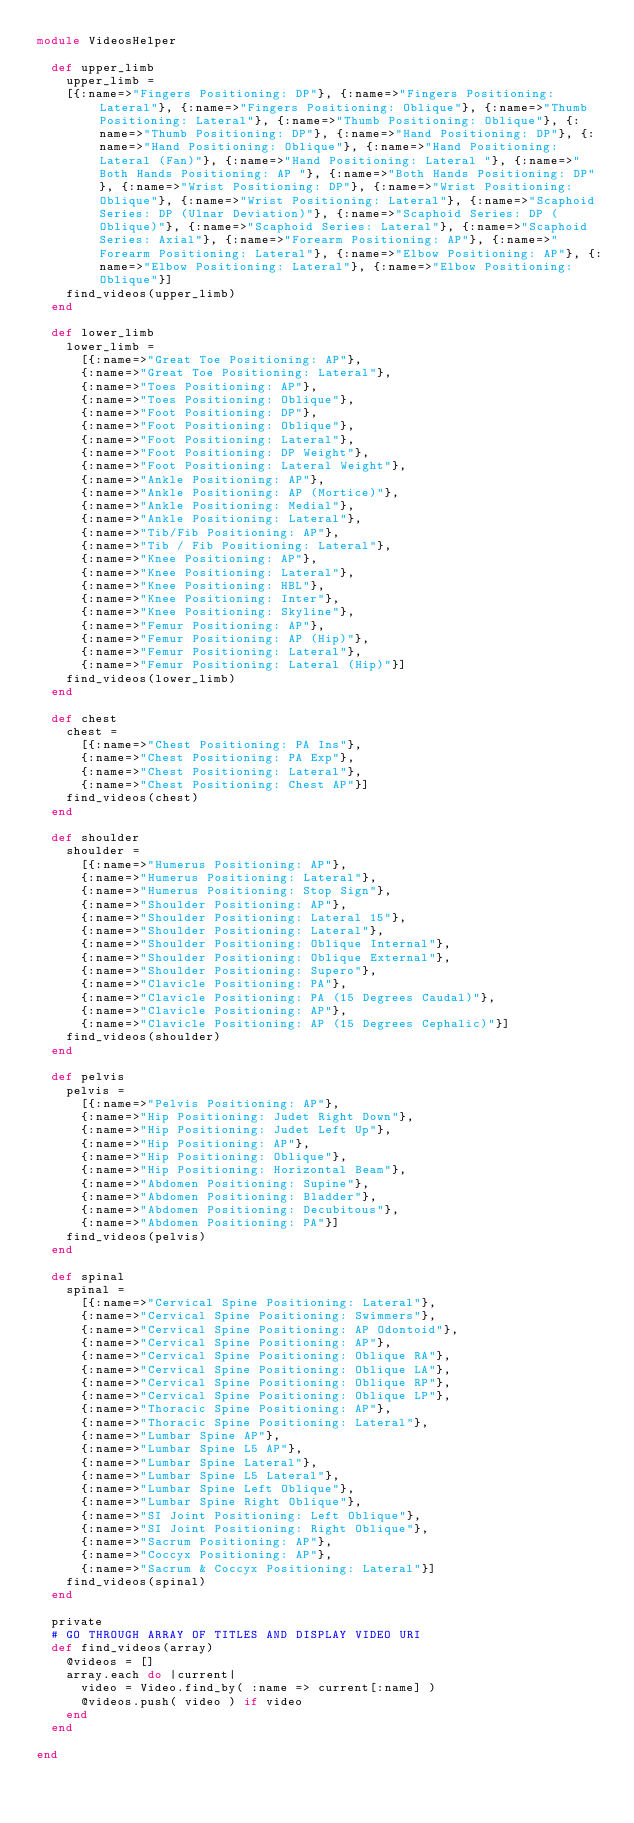<code> <loc_0><loc_0><loc_500><loc_500><_Ruby_>module VideosHelper

  def upper_limb
    upper_limb = 
    [{:name=>"Fingers Positioning: DP"}, {:name=>"Fingers Positioning: Lateral"}, {:name=>"Fingers Positioning: Oblique"}, {:name=>"Thumb Positioning: Lateral"}, {:name=>"Thumb Positioning: Oblique"}, {:name=>"Thumb Positioning: DP"}, {:name=>"Hand Positioning: DP"}, {:name=>"Hand Positioning: Oblique"}, {:name=>"Hand Positioning: Lateral (Fan)"}, {:name=>"Hand Positioning: Lateral "}, {:name=>"Both Hands Positioning: AP "}, {:name=>"Both Hands Positioning: DP"}, {:name=>"Wrist Positioning: DP"}, {:name=>"Wrist Positioning: Oblique"}, {:name=>"Wrist Positioning: Lateral"}, {:name=>"Scaphoid Series: DP (Ulnar Deviation)"}, {:name=>"Scaphoid Series: DP (Oblique)"}, {:name=>"Scaphoid Series: Lateral"}, {:name=>"Scaphoid Series: Axial"}, {:name=>"Forearm Positioning: AP"}, {:name=>"Forearm Positioning: Lateral"}, {:name=>"Elbow Positioning: AP"}, {:name=>"Elbow Positioning: Lateral"}, {:name=>"Elbow Positioning: Oblique"}]
    find_videos(upper_limb)
  end

  def lower_limb
    lower_limb = 
      [{:name=>"Great Toe Positioning: AP"},
      {:name=>"Great Toe Positioning: Lateral"},
      {:name=>"Toes Positioning: AP"},
      {:name=>"Toes Positioning: Oblique"},
      {:name=>"Foot Positioning: DP"},
      {:name=>"Foot Positioning: Oblique"},
      {:name=>"Foot Positioning: Lateral"},
      {:name=>"Foot Positioning: DP Weight"},
      {:name=>"Foot Positioning: Lateral Weight"},
      {:name=>"Ankle Positioning: AP"},
      {:name=>"Ankle Positioning: AP (Mortice)"},
      {:name=>"Ankle Positioning: Medial"},
      {:name=>"Ankle Positioning: Lateral"},
      {:name=>"Tib/Fib Positioning: AP"},
      {:name=>"Tib / Fib Positioning: Lateral"},
      {:name=>"Knee Positioning: AP"},
      {:name=>"Knee Positioning: Lateral"},
      {:name=>"Knee Positioning: HBL"},
      {:name=>"Knee Positioning: Inter"},
      {:name=>"Knee Positioning: Skyline"},
      {:name=>"Femur Positioning: AP"},
      {:name=>"Femur Positioning: AP (Hip)"},
      {:name=>"Femur Positioning: Lateral"},
      {:name=>"Femur Positioning: Lateral (Hip)"}]
    find_videos(lower_limb)
  end

  def chest
    chest =
      [{:name=>"Chest Positioning: PA Ins"},
      {:name=>"Chest Positioning: PA Exp"},
      {:name=>"Chest Positioning: Lateral"},
      {:name=>"Chest Positioning: Chest AP"}]
    find_videos(chest)
  end

  def shoulder
    shoulder = 
      [{:name=>"Humerus Positioning: AP"},
      {:name=>"Humerus Positioning: Lateral"},
      {:name=>"Humerus Positioning: Stop Sign"},
      {:name=>"Shoulder Positioning: AP"},
      {:name=>"Shoulder Positioning: Lateral 15"},
      {:name=>"Shoulder Positioning: Lateral"},
      {:name=>"Shoulder Positioning: Oblique Internal"},
      {:name=>"Shoulder Positioning: Oblique External"},
      {:name=>"Shoulder Positioning: Supero"},
      {:name=>"Clavicle Positioning: PA"},
      {:name=>"Clavicle Positioning: PA (15 Degrees Caudal)"},
      {:name=>"Clavicle Positioning: AP"},
      {:name=>"Clavicle Positioning: AP (15 Degrees Cephalic)"}]
    find_videos(shoulder)
  end

  def pelvis
    pelvis = 
      [{:name=>"Pelvis Positioning: AP"},
      {:name=>"Hip Positioning: Judet Right Down"},
      {:name=>"Hip Positioning: Judet Left Up"},
      {:name=>"Hip Positioning: AP"},
      {:name=>"Hip Positioning: Oblique"},
      {:name=>"Hip Positioning: Horizontal Beam"},
      {:name=>"Abdomen Positioning: Supine"},
      {:name=>"Abdomen Positioning: Bladder"},
      {:name=>"Abdomen Positioning: Decubitous"},
      {:name=>"Abdomen Positioning: PA"}]
    find_videos(pelvis)
  end

  def spinal
    spinal = 
      [{:name=>"Cervical Spine Positioning: Lateral"},
      {:name=>"Cervical Spine Positioning: Swimmers"},
      {:name=>"Cervical Spine Positioning: AP Odontoid"},
      {:name=>"Cervical Spine Positioning: AP"},
      {:name=>"Cervical Spine Positioning: Oblique RA"},
      {:name=>"Cervical Spine Positioning: Oblique LA"},
      {:name=>"Cervical Spine Positioning: Oblique RP"},
      {:name=>"Cervical Spine Positioning: Oblique LP"},
      {:name=>"Thoracic Spine Positioning: AP"},
      {:name=>"Thoracic Spine Positioning: Lateral"},
      {:name=>"Lumbar Spine AP"},
      {:name=>"Lumbar Spine L5 AP"},
      {:name=>"Lumbar Spine Lateral"},
      {:name=>"Lumbar Spine L5 Lateral"},
      {:name=>"Lumbar Spine Left Oblique"},
      {:name=>"Lumbar Spine Right Oblique"},
      {:name=>"SI Joint Positioning: Left Oblique"},
      {:name=>"SI Joint Positioning: Right Oblique"},
      {:name=>"Sacrum Positioning: AP"},
      {:name=>"Coccyx Positioning: AP"},
      {:name=>"Sacrum & Coccyx Positioning: Lateral"}]
    find_videos(spinal)
  end

  private
  # GO THROUGH ARRAY OF TITLES AND DISPLAY VIDEO URI
  def find_videos(array)
    @videos = []
    array.each do |current|
      video = Video.find_by( :name => current[:name] )
      @videos.push( video ) if video
    end
  end

end
</code> 